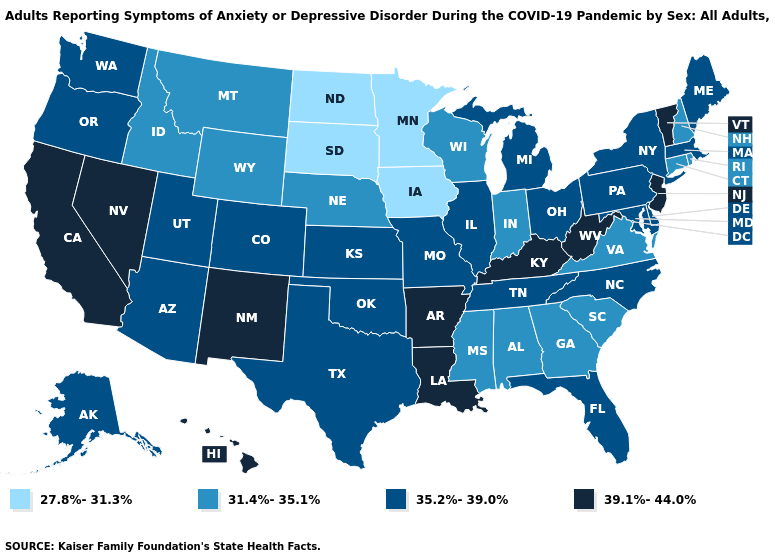Among the states that border Mississippi , does Alabama have the lowest value?
Answer briefly. Yes. Which states have the lowest value in the West?
Be succinct. Idaho, Montana, Wyoming. Name the states that have a value in the range 35.2%-39.0%?
Quick response, please. Alaska, Arizona, Colorado, Delaware, Florida, Illinois, Kansas, Maine, Maryland, Massachusetts, Michigan, Missouri, New York, North Carolina, Ohio, Oklahoma, Oregon, Pennsylvania, Tennessee, Texas, Utah, Washington. Does South Carolina have the same value as Alabama?
Answer briefly. Yes. Which states have the lowest value in the South?
Concise answer only. Alabama, Georgia, Mississippi, South Carolina, Virginia. Name the states that have a value in the range 31.4%-35.1%?
Be succinct. Alabama, Connecticut, Georgia, Idaho, Indiana, Mississippi, Montana, Nebraska, New Hampshire, Rhode Island, South Carolina, Virginia, Wisconsin, Wyoming. Does New York have the lowest value in the Northeast?
Short answer required. No. How many symbols are there in the legend?
Answer briefly. 4. Name the states that have a value in the range 31.4%-35.1%?
Write a very short answer. Alabama, Connecticut, Georgia, Idaho, Indiana, Mississippi, Montana, Nebraska, New Hampshire, Rhode Island, South Carolina, Virginia, Wisconsin, Wyoming. What is the value of Missouri?
Write a very short answer. 35.2%-39.0%. Name the states that have a value in the range 39.1%-44.0%?
Write a very short answer. Arkansas, California, Hawaii, Kentucky, Louisiana, Nevada, New Jersey, New Mexico, Vermont, West Virginia. What is the value of Indiana?
Keep it brief. 31.4%-35.1%. Which states have the lowest value in the West?
Give a very brief answer. Idaho, Montana, Wyoming. What is the value of New York?
Give a very brief answer. 35.2%-39.0%. What is the value of Connecticut?
Quick response, please. 31.4%-35.1%. 